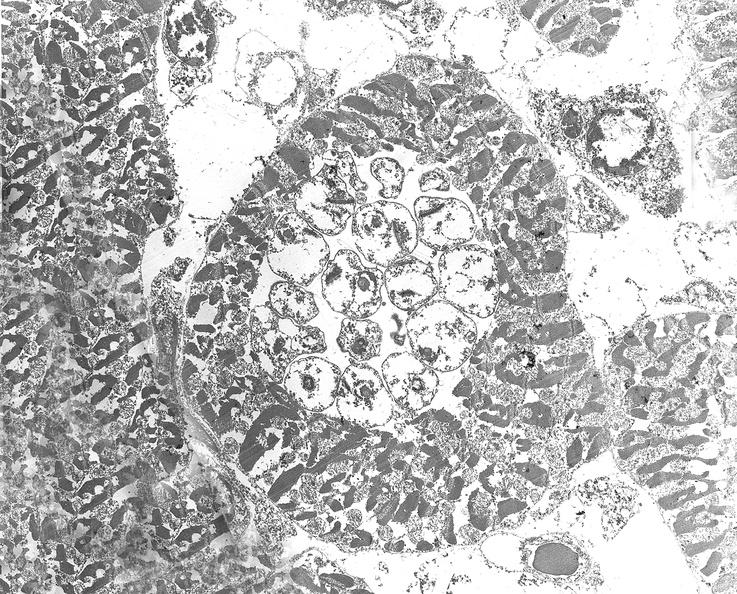does this image show chagas disease, acute, trypanasoma cruzi?
Answer the question using a single word or phrase. Yes 